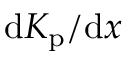Convert formula to latex. <formula><loc_0><loc_0><loc_500><loc_500>d K _ { p } / d x</formula> 